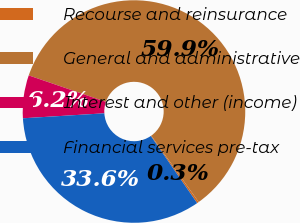<chart> <loc_0><loc_0><loc_500><loc_500><pie_chart><fcel>Recourse and reinsurance<fcel>General and administrative<fcel>Interest and other (income)<fcel>Financial services pre-tax<nl><fcel>0.27%<fcel>59.86%<fcel>6.23%<fcel>33.64%<nl></chart> 